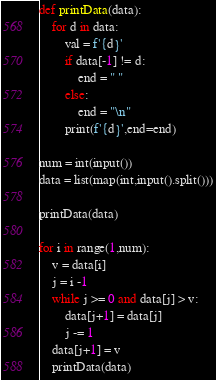Convert code to text. <code><loc_0><loc_0><loc_500><loc_500><_Python_>def printData(data):
    for d in data:
        val = f'{d}'
        if data[-1] != d:
            end = " "
        else:
            end = "\n"
        print(f'{d}',end=end)

num = int(input())
data = list(map(int,input().split()))

printData(data)

for i in range(1,num):
    v = data[i]
    j = i -1 
    while j >= 0 and data[j] > v:
        data[j+1] = data[j]
        j -= 1
    data[j+1] = v
    printData(data)

</code> 